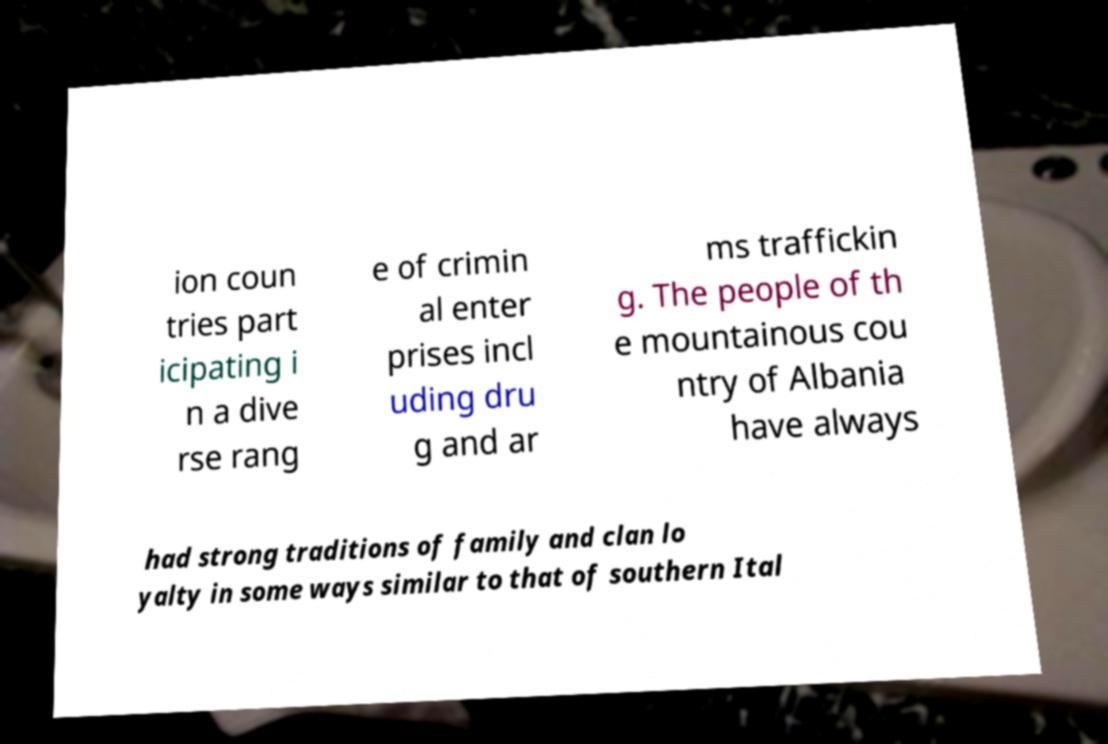Could you assist in decoding the text presented in this image and type it out clearly? ion coun tries part icipating i n a dive rse rang e of crimin al enter prises incl uding dru g and ar ms traffickin g. The people of th e mountainous cou ntry of Albania have always had strong traditions of family and clan lo yalty in some ways similar to that of southern Ital 